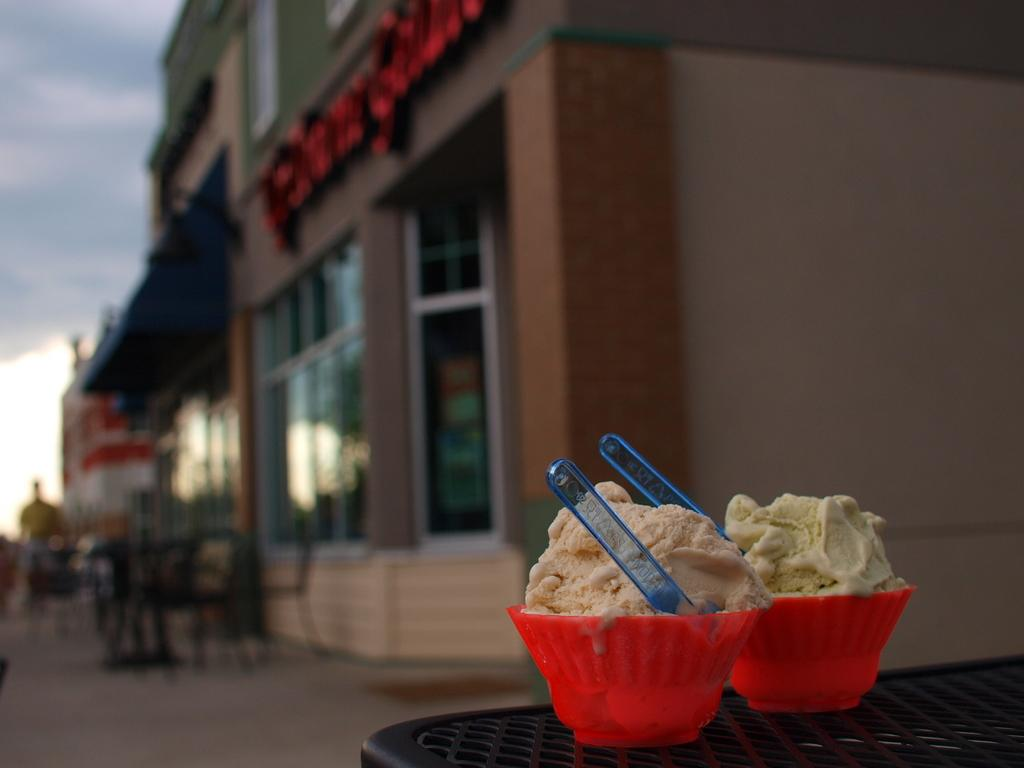What type of structures can be seen in the image? There are buildings in the image. What is written or displayed on a wall in the image? There is text on a wall in the image. What type of furniture is present in the image? There are chairs in the image. What type of food or dessert is visible in the image? There are ice cream cups in the image. What utensils are visible in the image? There are spoons in the image. What surface is present for placing items or sitting? There is a table in the image. How would you describe the weather or sky in the image? The sky is blue and cloudy in the image. How many men are wearing stockings in the image? There are no men or stockings present in the image. What direction is the wind blowing in the image? There is no indication of wind in the image. 